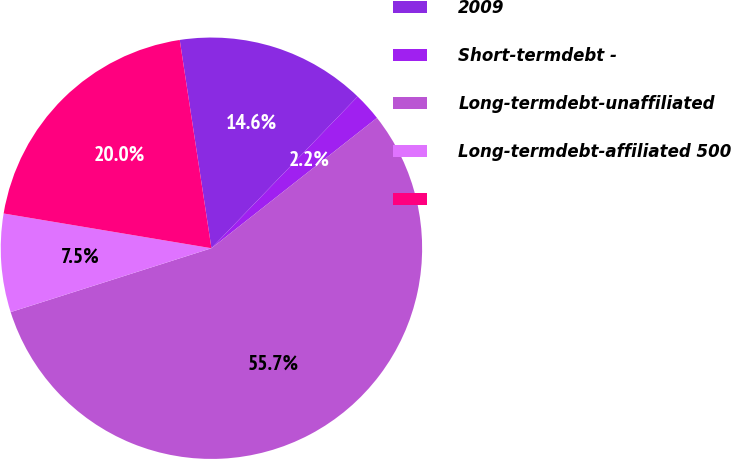Convert chart to OTSL. <chart><loc_0><loc_0><loc_500><loc_500><pie_chart><fcel>2009<fcel>Short-termdebt -<fcel>Long-termdebt-unaffiliated<fcel>Long-termdebt-affiliated 500<fcel>Unnamed: 4<nl><fcel>14.61%<fcel>2.18%<fcel>55.72%<fcel>7.54%<fcel>19.96%<nl></chart> 